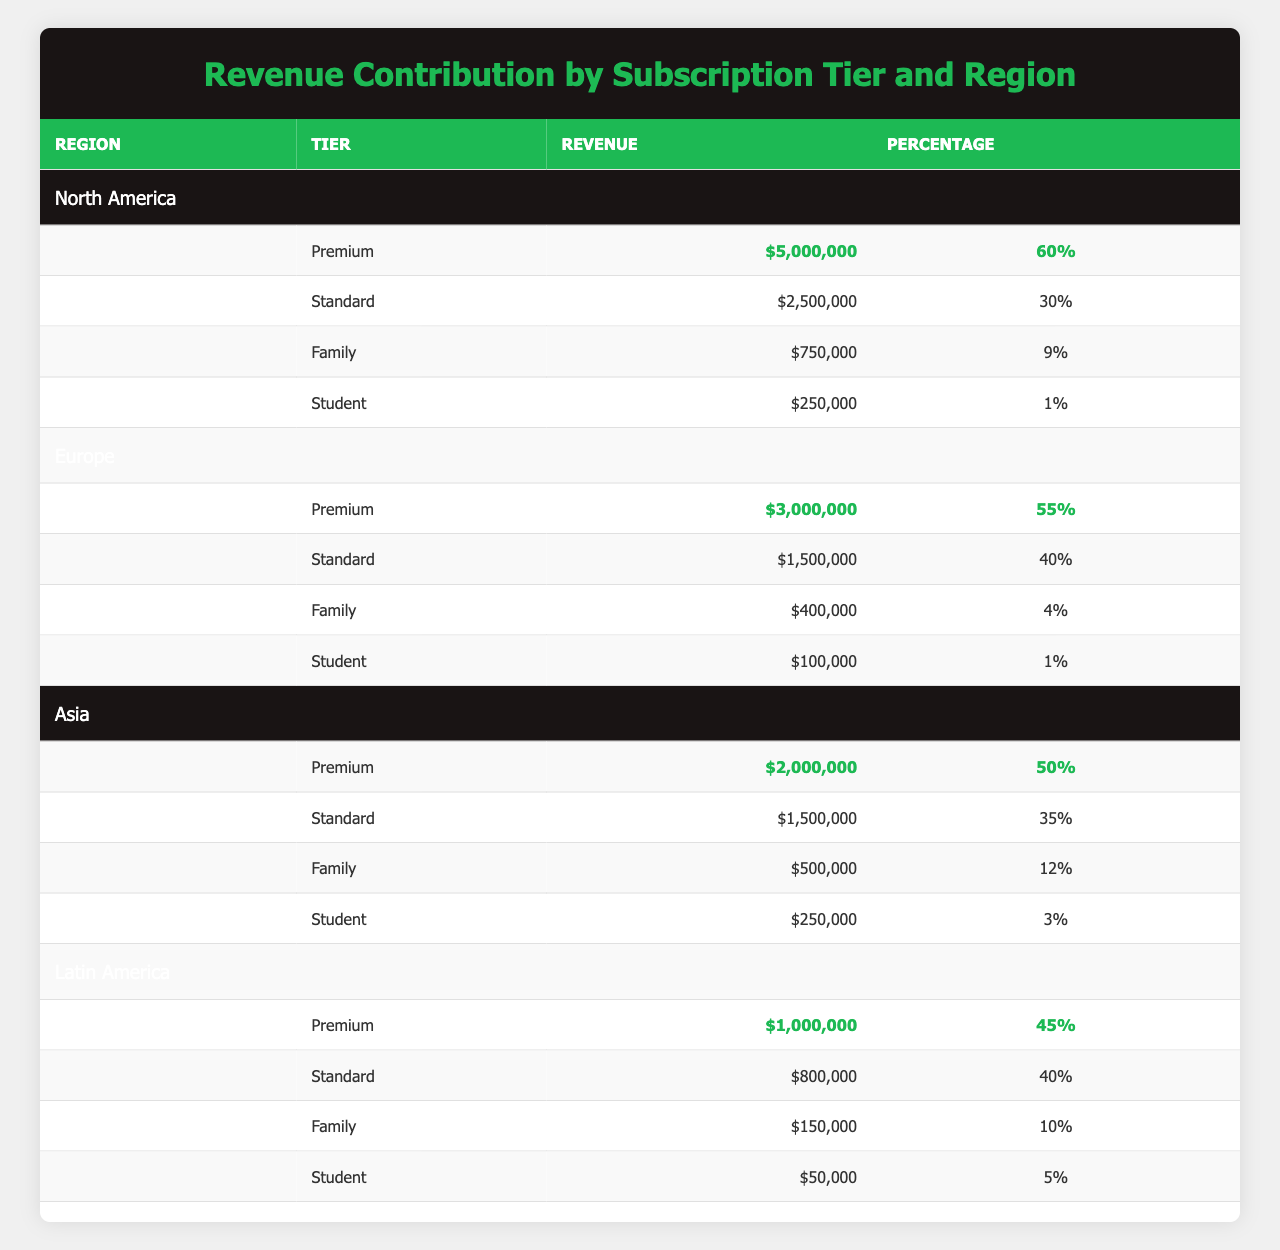What is the revenue contribution from the Premium tier in North America? From the North America region, the Premium tier's revenue is listed as $5,000,000.
Answer: $5,000,000 Which region has the highest revenue contribution from the Standard tier? The Standard tier's revenue for North America is $2,500,000, Europe is $1,500,000, Asia is $1,500,000, and Latin America is $800,000. North America has the highest value.
Answer: North America What percentage of revenue does the Family tier contribute in Europe? The table shows that the Family tier in Europe contributes $400,000, which is 4% of the total revenue for that region.
Answer: 4% Which continent has the lowest revenue contribution from the Student tier? The Student tier revenues are North America ($250,000), Europe ($100,000), Asia ($250,000), and Latin America ($50,000). Latin America has the lowest contribution of $50,000.
Answer: Latin America What is the total revenue from all tiers in Asia? Summing the revenues from Asia: $2,000,000 (Premium) + $1,500,000 (Standard) + $500,000 (Family) + $250,000 (Student) equals $4,250,000.
Answer: $4,250,000 Is the revenue contribution of the Premium tier in Latin America higher than that in Europe? The Premium tier contributes $1,000,000 in Latin America and $3,000,000 in Europe. $1,000,000 is not higher than $3,000,000.
Answer: No What is the average percentage revenue contribution of all tiers in North America? The percentages for North America are 60%, 30%, 9%, and 1%. The sum is 100%, and dividing by 4 tiers gives an average of 25%.
Answer: 25% What is the total revenue contribution from the Family and Student tiers in Europe? The Family tier revenue in Europe is $400,000, and the Student tier revenue is $100,000. Adding them gives $400,000 + $100,000 = $500,000.
Answer: $500,000 Is it true that the Standard tier contributes more than half of the total revenue in any region? In North America, it contributes 30%, in Europe 40%, in Asia 35%, and in Latin America 40%. None exceed 50%.
Answer: No How much more revenue does the Premium tier generate compared to the Family tier in Asia? The Premium tier in Asia generates $2,000,000 while the Family tier generates $500,000. The difference is $2,000,000 - $500,000 = $1,500,000.
Answer: $1,500,000 